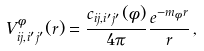Convert formula to latex. <formula><loc_0><loc_0><loc_500><loc_500>V ^ { \phi } _ { i j , i ^ { \prime } j ^ { \prime } } ( r ) = \frac { c _ { i j , i ^ { \prime } j ^ { \prime } } ( \phi ) } { 4 \pi } \frac { e ^ { - m _ { \phi } r } } { r } \, ,</formula> 